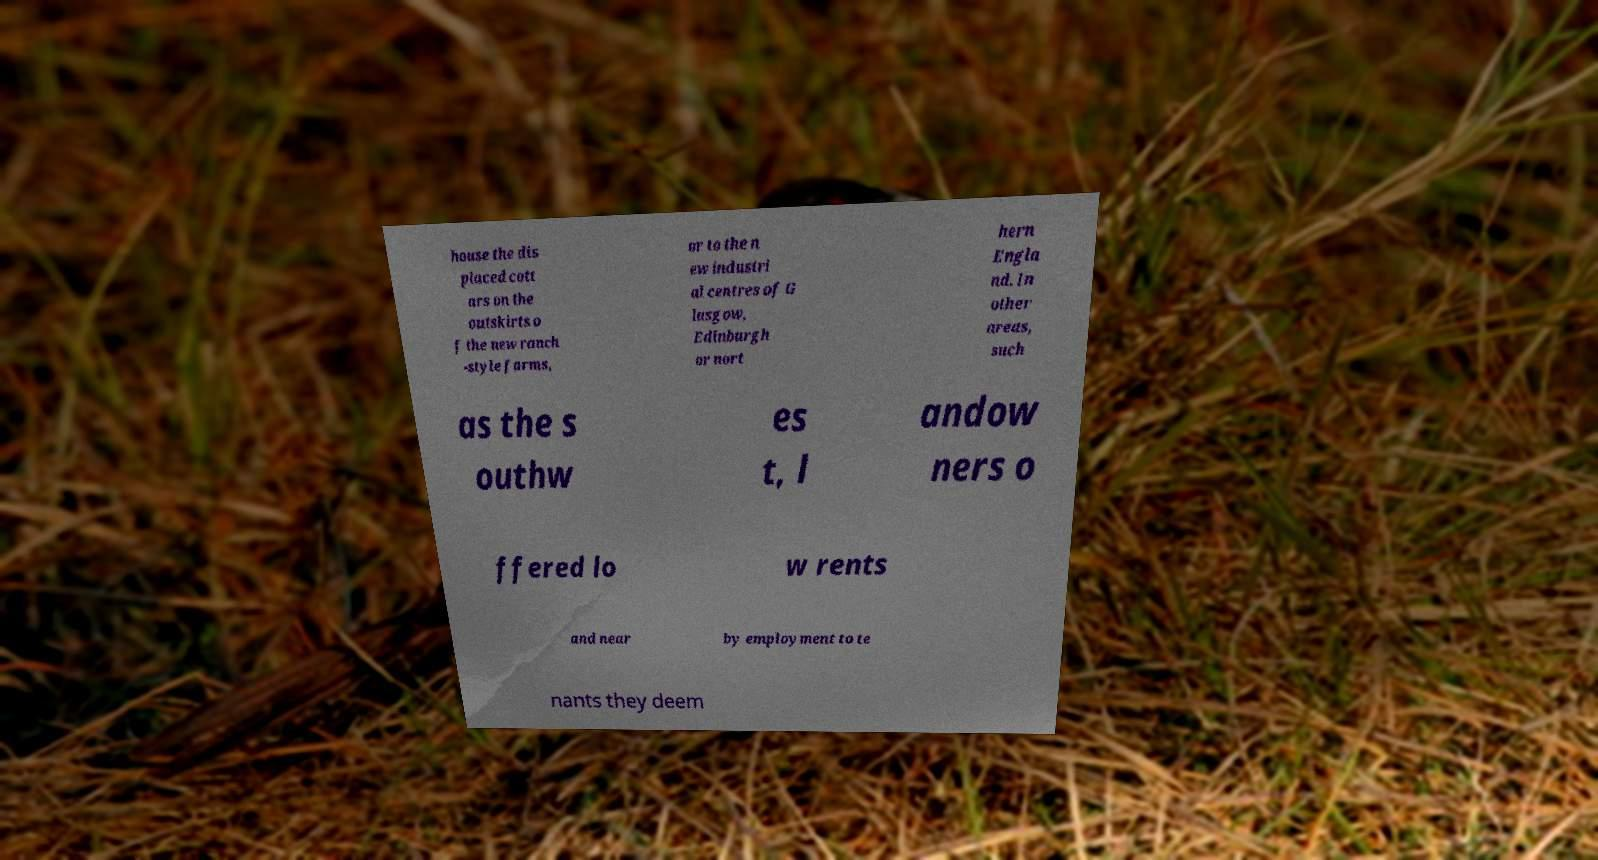There's text embedded in this image that I need extracted. Can you transcribe it verbatim? house the dis placed cott ars on the outskirts o f the new ranch -style farms, or to the n ew industri al centres of G lasgow, Edinburgh or nort hern Engla nd. In other areas, such as the s outhw es t, l andow ners o ffered lo w rents and near by employment to te nants they deem 